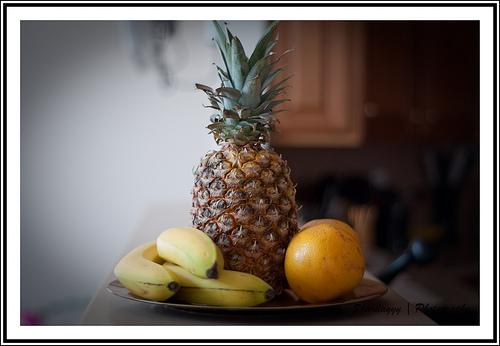What kind of tall fruit is in the center of the fruit plate?

Choices:
A) pineapple
B) banana
C) apple
D) strawberry pineapple 